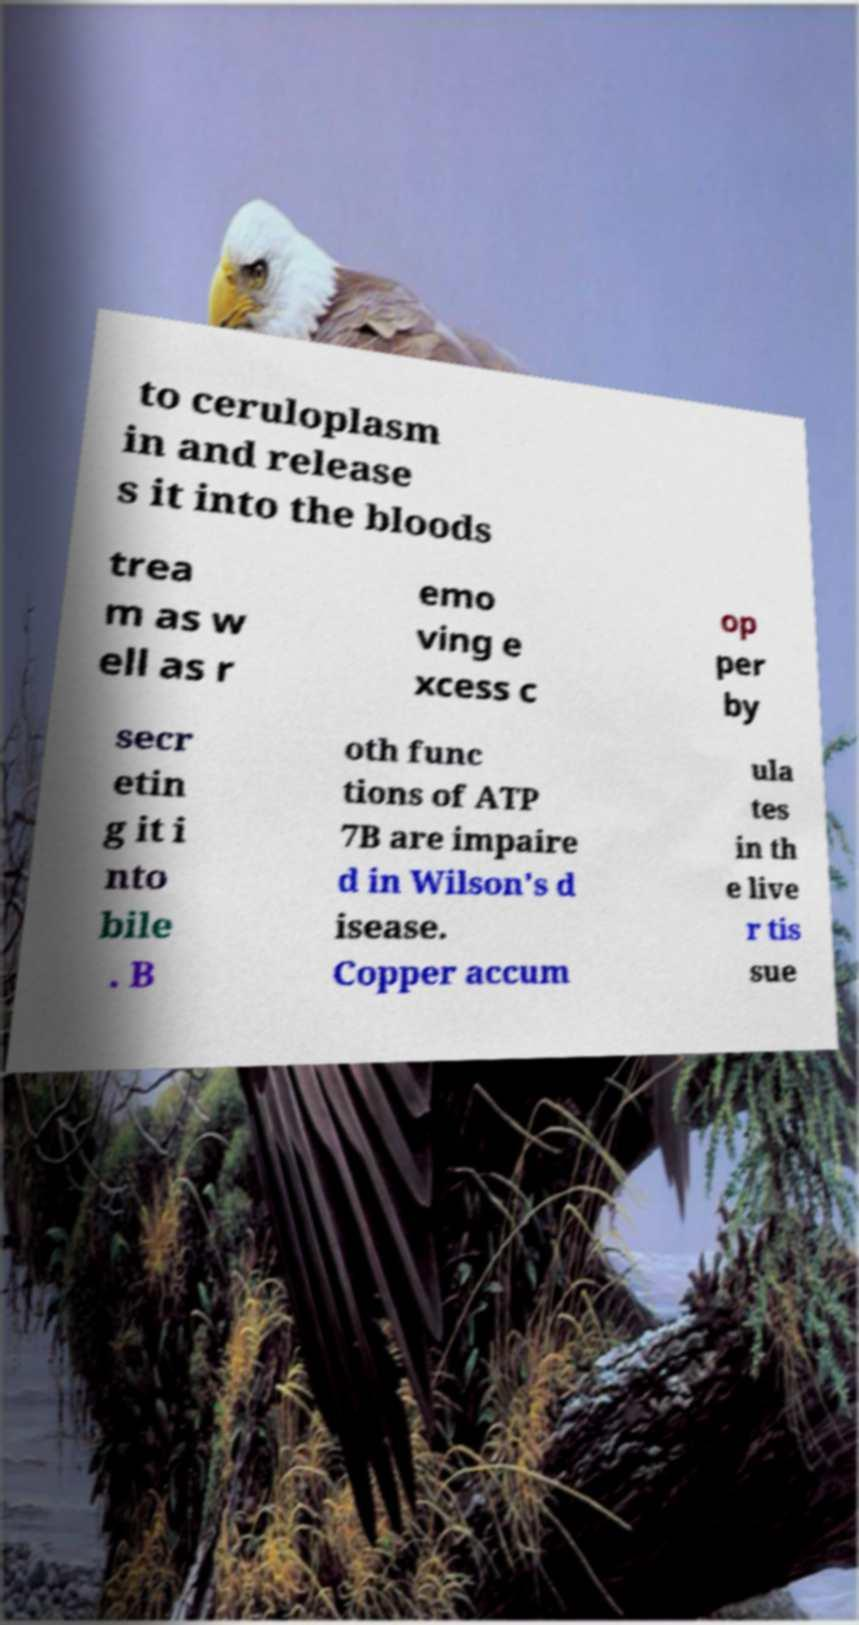Could you extract and type out the text from this image? to ceruloplasm in and release s it into the bloods trea m as w ell as r emo ving e xcess c op per by secr etin g it i nto bile . B oth func tions of ATP 7B are impaire d in Wilson's d isease. Copper accum ula tes in th e live r tis sue 